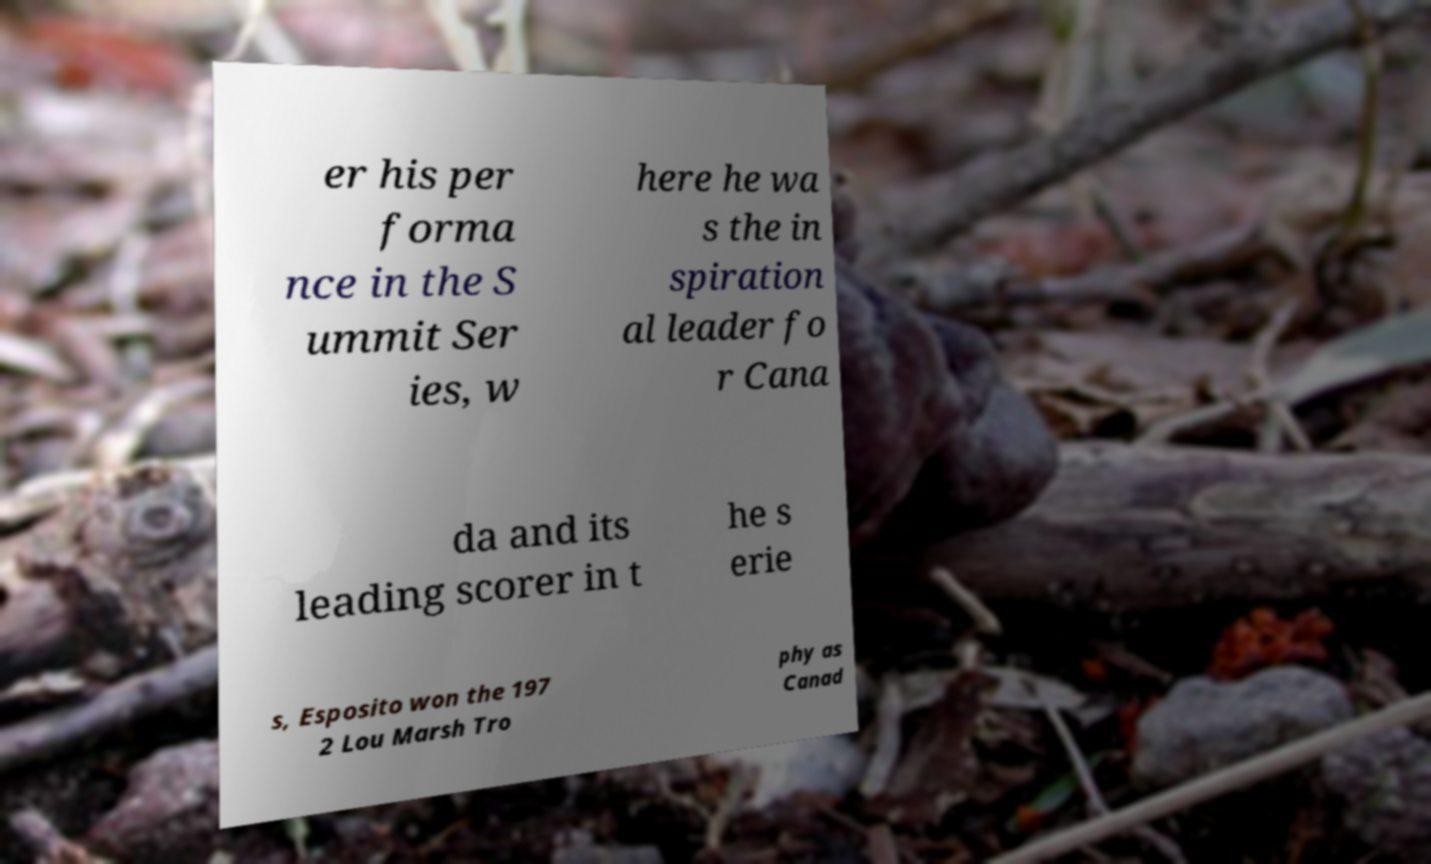Could you extract and type out the text from this image? er his per forma nce in the S ummit Ser ies, w here he wa s the in spiration al leader fo r Cana da and its leading scorer in t he s erie s, Esposito won the 197 2 Lou Marsh Tro phy as Canad 